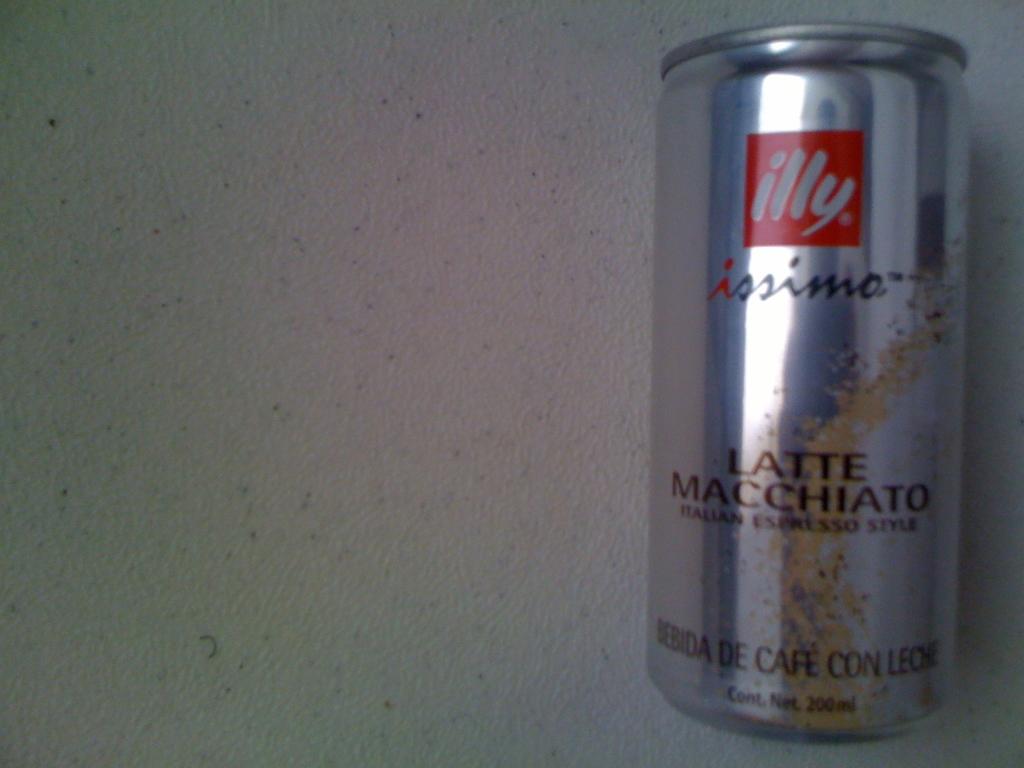The brand of coffee is?
Ensure brevity in your answer.  Illy. 